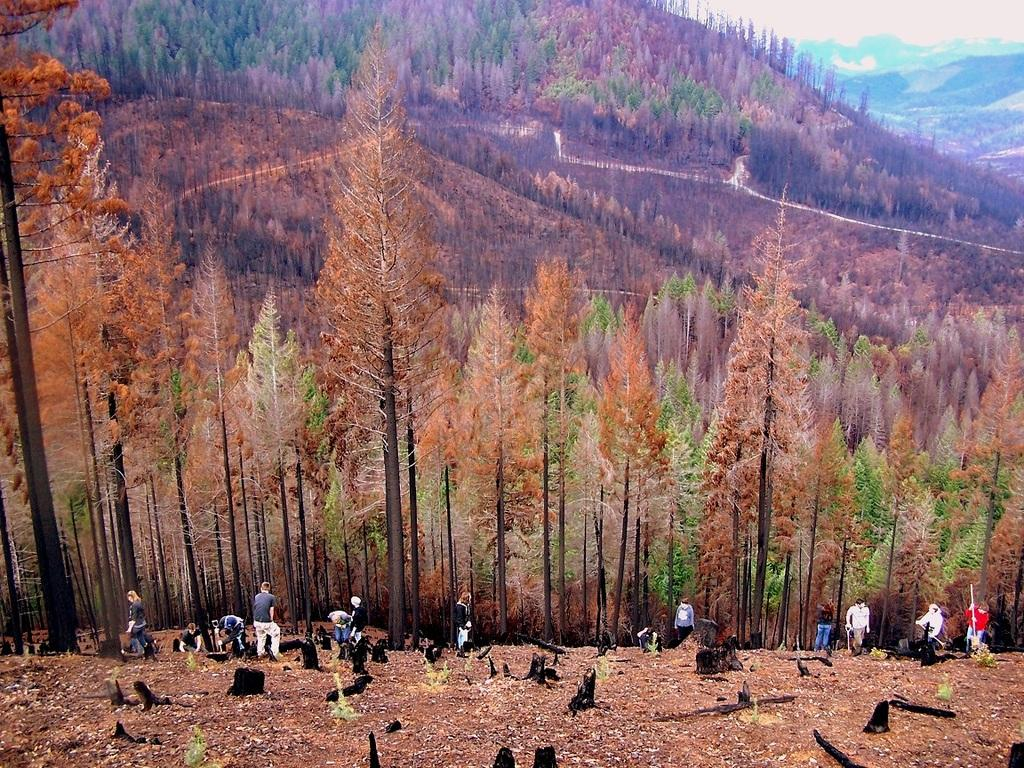What can be seen at the bottom of the image? There are persons standing at the bottom of the image. What type of natural environment is visible in the background of the image? There are trees and mountains in the background of the image. What type of poison is being used by the crowd in the image? There is no crowd present in the image, and no poison is mentioned or depicted. 